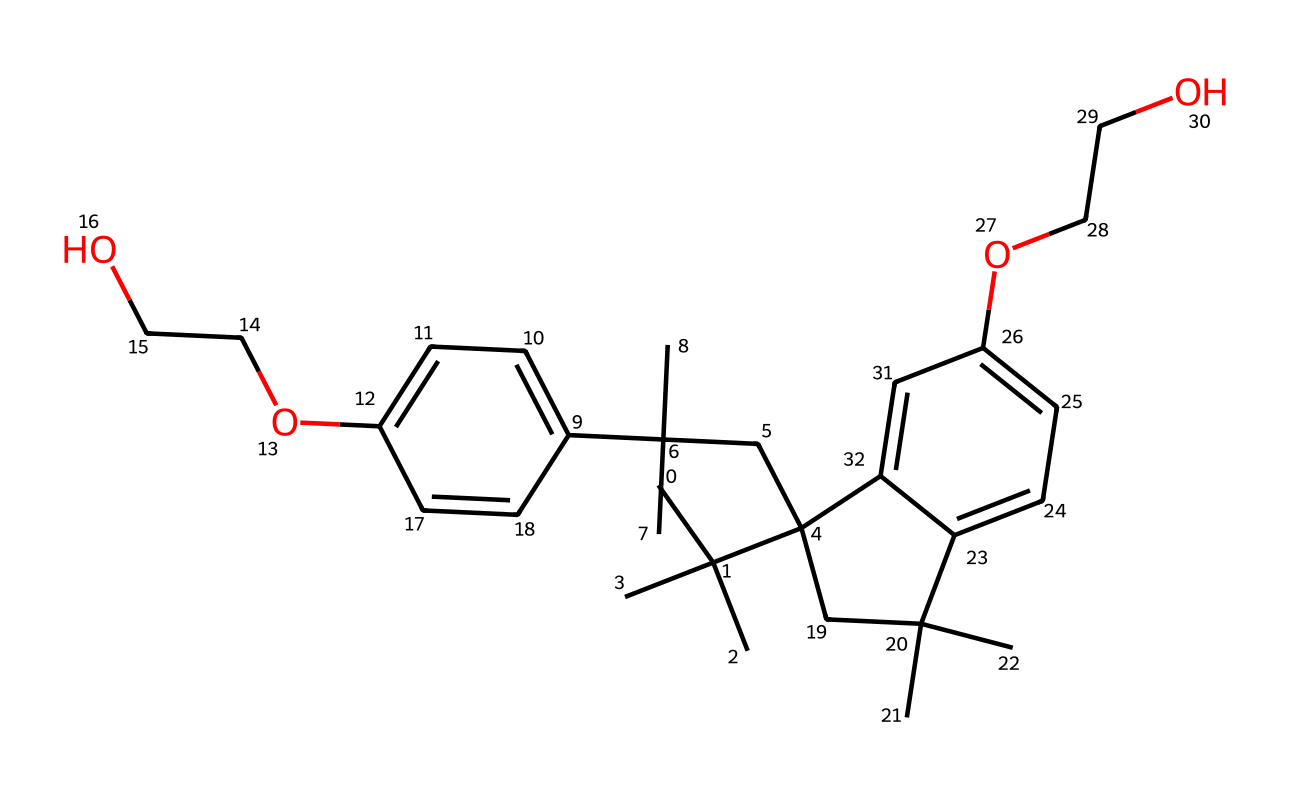how many carbon atoms are present in this structure? Count the number of carbon (C) atoms represented in the SMILES notation. In this case, the notation indicates a total of 24 carbon atoms in the chemical structure.
Answer: 24 what type of chemical is represented by this SMILES? The chemical structure indicates that it is a polyphenolic compound, as suggested by the presence of multiple aromatic rings connected by aliphatic carbon chains.
Answer: polyphenolic what is the degree of unsaturation in this chemical? Determine the degree of unsaturation by considering the number of rings and double bonds present. In this case, there are two aromatic rings and no double bonds indicated outside these, resulting in a total degree of unsaturation of 4.
Answer: 4 how many hydroxyl (-OH) groups are in this structure? Identify the functional groups within the SMILES. The hydroxyl groups are indicated by “O” linked to hydrogen, which appear twice in the structure.
Answer: 2 does this chemical likely exhibit hydrophobic or hydrophilic properties? Analyze the structure for functional groups that promote solubility. The presence of hydroxyl groups suggests hydrophilic properties, while the large hydrophobic carbon chain indicates both attributes. However, the more dominant group indicates it likely leans towards hydrophilic.
Answer: hydrophilic what is the primary use of this compound regarding public property? Given its chemical stability and resistance to solvents, this compound is used widely as a protective coating to prevent vandalism, especially from spray paints.
Answer: protective coating 